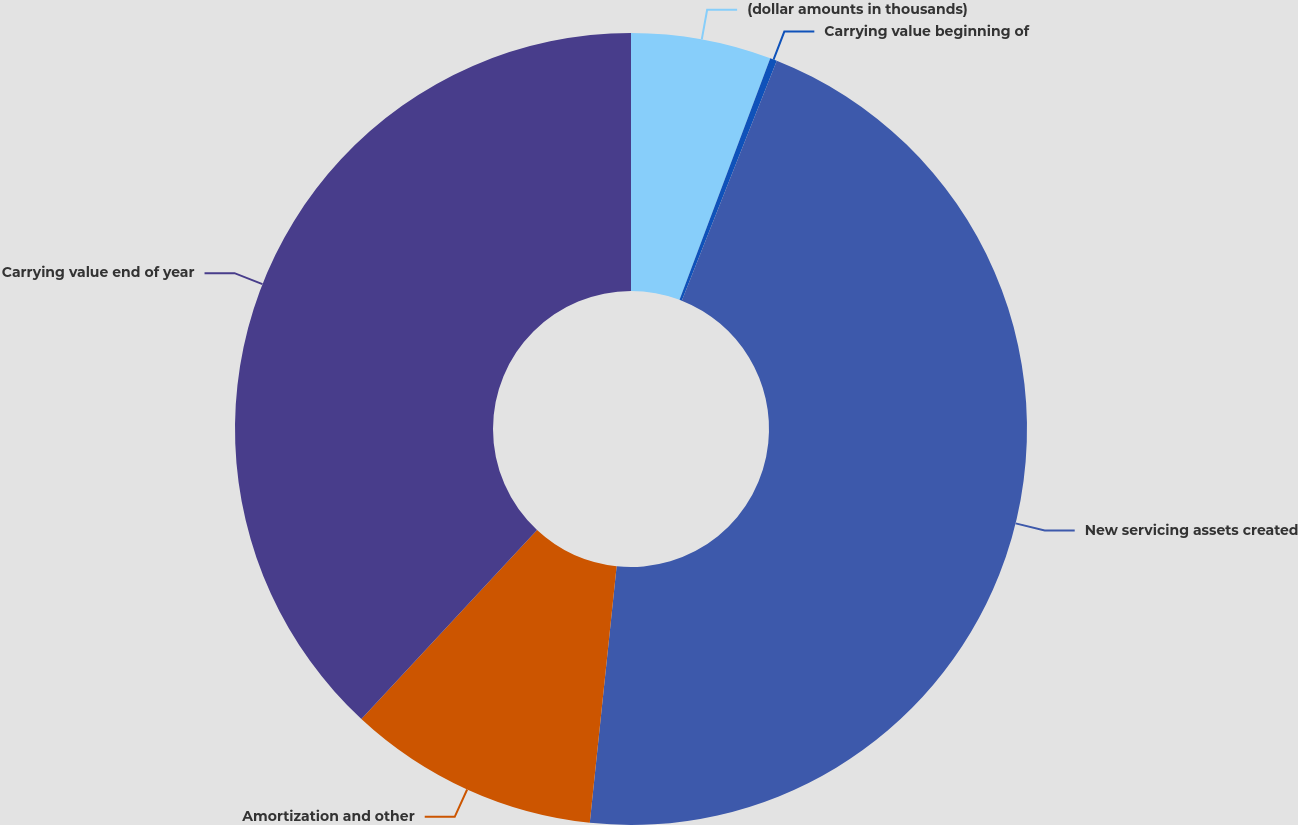<chart> <loc_0><loc_0><loc_500><loc_500><pie_chart><fcel>(dollar amounts in thousands)<fcel>Carrying value beginning of<fcel>New servicing assets created<fcel>Amortization and other<fcel>Carrying value end of year<nl><fcel>5.72%<fcel>0.28%<fcel>45.66%<fcel>10.26%<fcel>38.08%<nl></chart> 